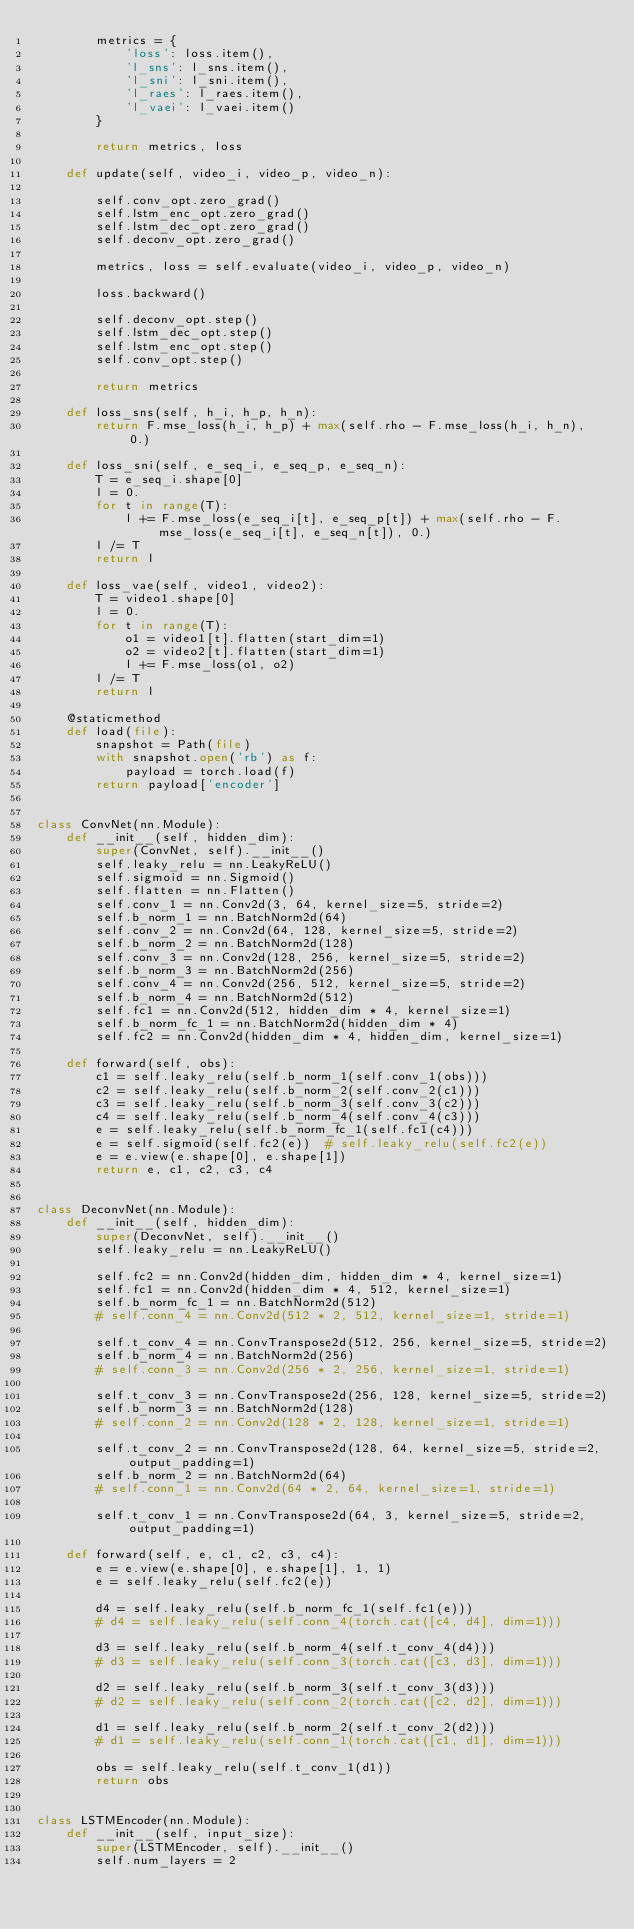Convert code to text. <code><loc_0><loc_0><loc_500><loc_500><_Python_>        metrics = {
            'loss': loss.item(),
            'l_sns': l_sns.item(),
            'l_sni': l_sni.item(),
            'l_raes': l_raes.item(),
            'l_vaei': l_vaei.item()
        }

        return metrics, loss

    def update(self, video_i, video_p, video_n):

        self.conv_opt.zero_grad()
        self.lstm_enc_opt.zero_grad()
        self.lstm_dec_opt.zero_grad()
        self.deconv_opt.zero_grad()

        metrics, loss = self.evaluate(video_i, video_p, video_n)

        loss.backward()

        self.deconv_opt.step()
        self.lstm_dec_opt.step()
        self.lstm_enc_opt.step()
        self.conv_opt.step()

        return metrics

    def loss_sns(self, h_i, h_p, h_n):
        return F.mse_loss(h_i, h_p) + max(self.rho - F.mse_loss(h_i, h_n), 0.)

    def loss_sni(self, e_seq_i, e_seq_p, e_seq_n):
        T = e_seq_i.shape[0]
        l = 0.
        for t in range(T):
            l += F.mse_loss(e_seq_i[t], e_seq_p[t]) + max(self.rho - F.mse_loss(e_seq_i[t], e_seq_n[t]), 0.)
        l /= T
        return l

    def loss_vae(self, video1, video2):
        T = video1.shape[0]
        l = 0.
        for t in range(T):
            o1 = video1[t].flatten(start_dim=1)
            o2 = video2[t].flatten(start_dim=1)
            l += F.mse_loss(o1, o2)
        l /= T
        return l

    @staticmethod
    def load(file):
        snapshot = Path(file)
        with snapshot.open('rb') as f:
            payload = torch.load(f)
        return payload['encoder']


class ConvNet(nn.Module):
    def __init__(self, hidden_dim):
        super(ConvNet, self).__init__()
        self.leaky_relu = nn.LeakyReLU()
        self.sigmoid = nn.Sigmoid()
        self.flatten = nn.Flatten()
        self.conv_1 = nn.Conv2d(3, 64, kernel_size=5, stride=2)
        self.b_norm_1 = nn.BatchNorm2d(64)
        self.conv_2 = nn.Conv2d(64, 128, kernel_size=5, stride=2)
        self.b_norm_2 = nn.BatchNorm2d(128)
        self.conv_3 = nn.Conv2d(128, 256, kernel_size=5, stride=2)
        self.b_norm_3 = nn.BatchNorm2d(256)
        self.conv_4 = nn.Conv2d(256, 512, kernel_size=5, stride=2)
        self.b_norm_4 = nn.BatchNorm2d(512)
        self.fc1 = nn.Conv2d(512, hidden_dim * 4, kernel_size=1)
        self.b_norm_fc_1 = nn.BatchNorm2d(hidden_dim * 4)
        self.fc2 = nn.Conv2d(hidden_dim * 4, hidden_dim, kernel_size=1)

    def forward(self, obs):
        c1 = self.leaky_relu(self.b_norm_1(self.conv_1(obs)))
        c2 = self.leaky_relu(self.b_norm_2(self.conv_2(c1)))
        c3 = self.leaky_relu(self.b_norm_3(self.conv_3(c2)))
        c4 = self.leaky_relu(self.b_norm_4(self.conv_4(c3)))
        e = self.leaky_relu(self.b_norm_fc_1(self.fc1(c4)))
        e = self.sigmoid(self.fc2(e))  # self.leaky_relu(self.fc2(e))
        e = e.view(e.shape[0], e.shape[1])
        return e, c1, c2, c3, c4


class DeconvNet(nn.Module):
    def __init__(self, hidden_dim):
        super(DeconvNet, self).__init__()
        self.leaky_relu = nn.LeakyReLU()

        self.fc2 = nn.Conv2d(hidden_dim, hidden_dim * 4, kernel_size=1)
        self.fc1 = nn.Conv2d(hidden_dim * 4, 512, kernel_size=1)
        self.b_norm_fc_1 = nn.BatchNorm2d(512)
        # self.conn_4 = nn.Conv2d(512 * 2, 512, kernel_size=1, stride=1)

        self.t_conv_4 = nn.ConvTranspose2d(512, 256, kernel_size=5, stride=2)
        self.b_norm_4 = nn.BatchNorm2d(256)
        # self.conn_3 = nn.Conv2d(256 * 2, 256, kernel_size=1, stride=1)

        self.t_conv_3 = nn.ConvTranspose2d(256, 128, kernel_size=5, stride=2)
        self.b_norm_3 = nn.BatchNorm2d(128)
        # self.conn_2 = nn.Conv2d(128 * 2, 128, kernel_size=1, stride=1)

        self.t_conv_2 = nn.ConvTranspose2d(128, 64, kernel_size=5, stride=2, output_padding=1)
        self.b_norm_2 = nn.BatchNorm2d(64)
        # self.conn_1 = nn.Conv2d(64 * 2, 64, kernel_size=1, stride=1)

        self.t_conv_1 = nn.ConvTranspose2d(64, 3, kernel_size=5, stride=2, output_padding=1)

    def forward(self, e, c1, c2, c3, c4):
        e = e.view(e.shape[0], e.shape[1], 1, 1)
        e = self.leaky_relu(self.fc2(e))

        d4 = self.leaky_relu(self.b_norm_fc_1(self.fc1(e)))
        # d4 = self.leaky_relu(self.conn_4(torch.cat([c4, d4], dim=1)))

        d3 = self.leaky_relu(self.b_norm_4(self.t_conv_4(d4)))
        # d3 = self.leaky_relu(self.conn_3(torch.cat([c3, d3], dim=1)))

        d2 = self.leaky_relu(self.b_norm_3(self.t_conv_3(d3)))
        # d2 = self.leaky_relu(self.conn_2(torch.cat([c2, d2], dim=1)))

        d1 = self.leaky_relu(self.b_norm_2(self.t_conv_2(d2)))
        # d1 = self.leaky_relu(self.conn_1(torch.cat([c1, d1], dim=1)))

        obs = self.leaky_relu(self.t_conv_1(d1))
        return obs


class LSTMEncoder(nn.Module):
    def __init__(self, input_size):
        super(LSTMEncoder, self).__init__()
        self.num_layers = 2</code> 